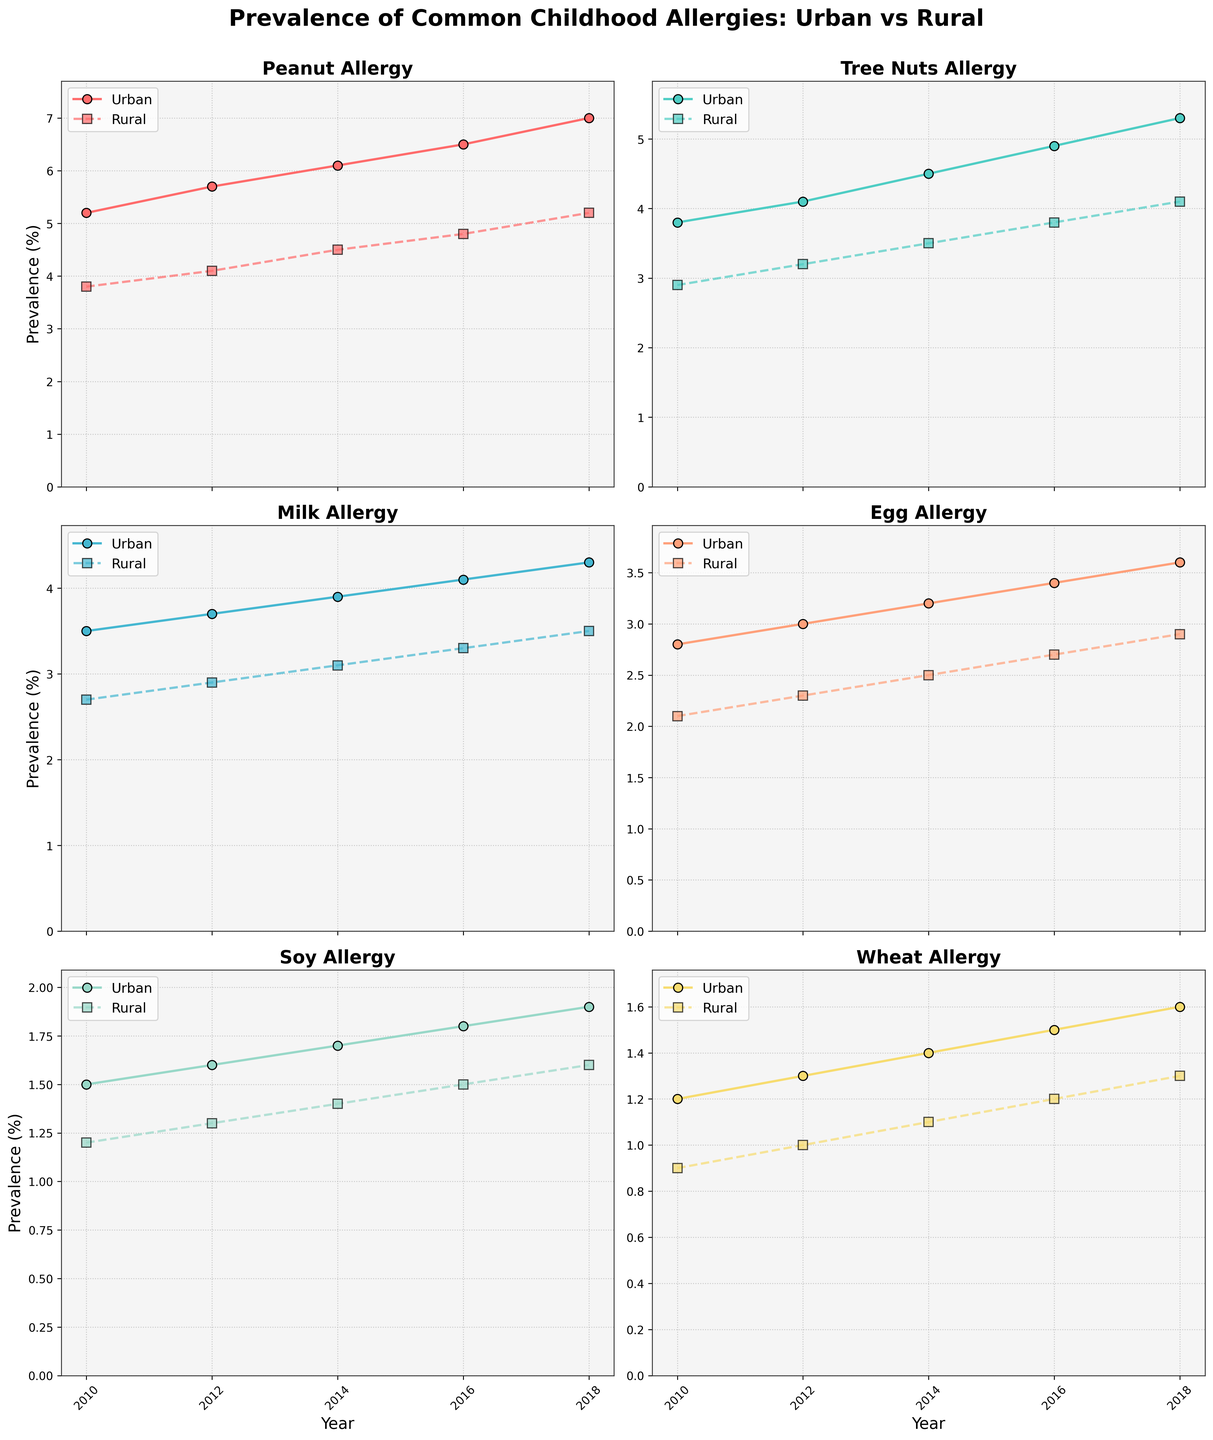How does the prevalence of peanut allergy in urban settings change from 2010 to 2018? By observing the plot for peanut allergy, you notice the line for urban prevalence increasing over time. It's at 5.2% in 2010 and rises to 7.0% in 2018.
Answer: It increases How does the prevalence of milk allergy in rural settings compare to urban settings in 2018? Look at the graph for milk allergies in 2018. Urban prevalence is 4.3% while rural prevalence is 3.5%.
Answer: Urban is higher Which allergy shows the smallest difference in prevalence between urban and rural settings in 2010? By examining all the graphs for 2010, the smallest difference is seen in the soy allergy graph: Urban is 1.5% and rural is 1.2%.
Answer: Soy What is the average prevalence of tree nut allergy in rural areas from 2010 to 2018? Add the rural prevalence values for tree nuts for each year (2.9 + 3.2 + 3.5 + 3.8 + 4.1) and divide by 5 (the number of years), which equals 3.5%.
Answer: 3.5% By how much did the prevalence of egg allergy in urban settings increase from 2010 to 2018? Find the prevalence in 2010 (2.8%) and in 2018 (3.6%), then subtract 2.8% from 3.6%, which gives an increase of 0.8%.
Answer: 0.8% In which year is the prevalence of wheat allergy the same in both urban and rural settings? Examine the plot for wheat allergy and compare the urban and rural prevalence lines across the years. There is no year where the lines intersect or values match.
Answer: No year Which allergy shows the greatest overall increase in rural prevalence from 2010 to 2018? Consider each allergy plot and calculate the difference from 2010 to 2018 for rural prevalence. Peanut allergy has the largest increase (5.2% - 3.8% = 1.4%).
Answer: Peanut Among all the allergies, which one has the highest prevalence in urban settings in 2018? Look at the urban prevalence values for all allergies in 2018: Peanut allergy has the highest prevalence at 7.0%.
Answer: Peanut How does the trend in rural prevalence of soy allergy compare to the trend in urban prevalence from 2010 to 2018? Observe the soy allergy plot. Both urban and rural prevalence lines show a steady and similar upward trend from 1.5% and 1.2% in 2010 to 1.9% and 1.6% in 2018, respectively.
Answer: Similar upward trend 